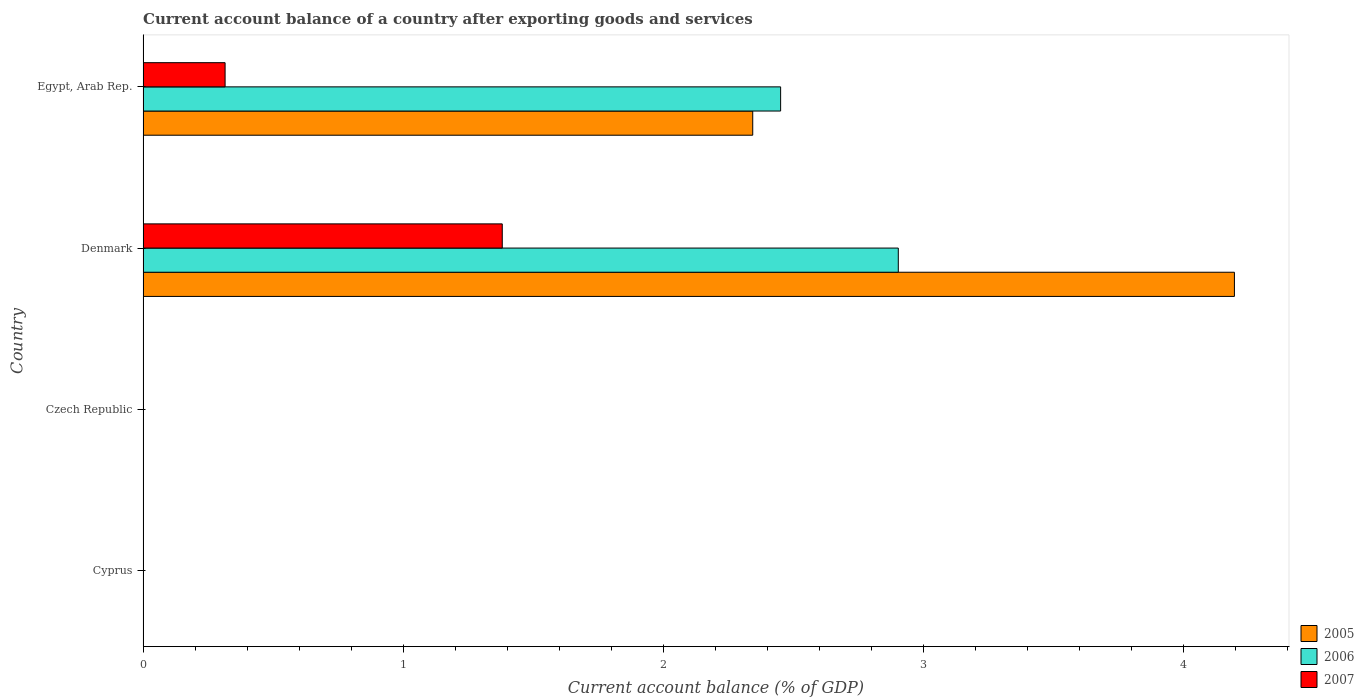How many bars are there on the 1st tick from the bottom?
Make the answer very short. 0. What is the label of the 4th group of bars from the top?
Your response must be concise. Cyprus. What is the account balance in 2007 in Czech Republic?
Provide a succinct answer. 0. Across all countries, what is the maximum account balance in 2007?
Your answer should be compact. 1.38. In which country was the account balance in 2007 maximum?
Provide a succinct answer. Denmark. What is the total account balance in 2005 in the graph?
Make the answer very short. 6.54. What is the difference between the account balance in 2006 in Denmark and that in Egypt, Arab Rep.?
Provide a short and direct response. 0.45. What is the difference between the account balance in 2005 in Denmark and the account balance in 2006 in Egypt, Arab Rep.?
Offer a very short reply. 1.75. What is the average account balance in 2007 per country?
Give a very brief answer. 0.42. What is the difference between the account balance in 2007 and account balance in 2005 in Egypt, Arab Rep.?
Give a very brief answer. -2.03. In how many countries, is the account balance in 2005 greater than 1.2 %?
Your answer should be compact. 2. What is the ratio of the account balance in 2005 in Denmark to that in Egypt, Arab Rep.?
Offer a very short reply. 1.79. Is the account balance in 2007 in Denmark less than that in Egypt, Arab Rep.?
Provide a short and direct response. No. Is the difference between the account balance in 2007 in Denmark and Egypt, Arab Rep. greater than the difference between the account balance in 2005 in Denmark and Egypt, Arab Rep.?
Ensure brevity in your answer.  No. What is the difference between the highest and the lowest account balance in 2006?
Your answer should be very brief. 2.9. In how many countries, is the account balance in 2007 greater than the average account balance in 2007 taken over all countries?
Your answer should be very brief. 1. Is it the case that in every country, the sum of the account balance in 2007 and account balance in 2006 is greater than the account balance in 2005?
Offer a very short reply. No. How many bars are there?
Give a very brief answer. 6. Are all the bars in the graph horizontal?
Provide a short and direct response. Yes. Are the values on the major ticks of X-axis written in scientific E-notation?
Your response must be concise. No. Where does the legend appear in the graph?
Provide a short and direct response. Bottom right. What is the title of the graph?
Your answer should be very brief. Current account balance of a country after exporting goods and services. What is the label or title of the X-axis?
Your answer should be compact. Current account balance (% of GDP). What is the Current account balance (% of GDP) in 2005 in Cyprus?
Make the answer very short. 0. What is the Current account balance (% of GDP) of 2006 in Cyprus?
Provide a succinct answer. 0. What is the Current account balance (% of GDP) of 2006 in Czech Republic?
Your answer should be very brief. 0. What is the Current account balance (% of GDP) of 2005 in Denmark?
Make the answer very short. 4.2. What is the Current account balance (% of GDP) of 2006 in Denmark?
Keep it short and to the point. 2.9. What is the Current account balance (% of GDP) in 2007 in Denmark?
Your answer should be very brief. 1.38. What is the Current account balance (% of GDP) in 2005 in Egypt, Arab Rep.?
Give a very brief answer. 2.34. What is the Current account balance (% of GDP) of 2006 in Egypt, Arab Rep.?
Provide a succinct answer. 2.45. What is the Current account balance (% of GDP) of 2007 in Egypt, Arab Rep.?
Offer a very short reply. 0.32. Across all countries, what is the maximum Current account balance (% of GDP) in 2005?
Give a very brief answer. 4.2. Across all countries, what is the maximum Current account balance (% of GDP) in 2006?
Your answer should be very brief. 2.9. Across all countries, what is the maximum Current account balance (% of GDP) in 2007?
Make the answer very short. 1.38. Across all countries, what is the minimum Current account balance (% of GDP) in 2005?
Your answer should be very brief. 0. Across all countries, what is the minimum Current account balance (% of GDP) in 2006?
Offer a very short reply. 0. Across all countries, what is the minimum Current account balance (% of GDP) in 2007?
Offer a terse response. 0. What is the total Current account balance (% of GDP) in 2005 in the graph?
Ensure brevity in your answer.  6.54. What is the total Current account balance (% of GDP) in 2006 in the graph?
Provide a short and direct response. 5.36. What is the total Current account balance (% of GDP) in 2007 in the graph?
Offer a terse response. 1.7. What is the difference between the Current account balance (% of GDP) in 2005 in Denmark and that in Egypt, Arab Rep.?
Keep it short and to the point. 1.85. What is the difference between the Current account balance (% of GDP) in 2006 in Denmark and that in Egypt, Arab Rep.?
Keep it short and to the point. 0.45. What is the difference between the Current account balance (% of GDP) of 2007 in Denmark and that in Egypt, Arab Rep.?
Provide a short and direct response. 1.07. What is the difference between the Current account balance (% of GDP) in 2005 in Denmark and the Current account balance (% of GDP) in 2006 in Egypt, Arab Rep.?
Ensure brevity in your answer.  1.75. What is the difference between the Current account balance (% of GDP) of 2005 in Denmark and the Current account balance (% of GDP) of 2007 in Egypt, Arab Rep.?
Provide a succinct answer. 3.88. What is the difference between the Current account balance (% of GDP) of 2006 in Denmark and the Current account balance (% of GDP) of 2007 in Egypt, Arab Rep.?
Offer a terse response. 2.59. What is the average Current account balance (% of GDP) in 2005 per country?
Ensure brevity in your answer.  1.64. What is the average Current account balance (% of GDP) of 2006 per country?
Your answer should be compact. 1.34. What is the average Current account balance (% of GDP) in 2007 per country?
Keep it short and to the point. 0.42. What is the difference between the Current account balance (% of GDP) in 2005 and Current account balance (% of GDP) in 2006 in Denmark?
Make the answer very short. 1.29. What is the difference between the Current account balance (% of GDP) of 2005 and Current account balance (% of GDP) of 2007 in Denmark?
Offer a very short reply. 2.82. What is the difference between the Current account balance (% of GDP) of 2006 and Current account balance (% of GDP) of 2007 in Denmark?
Provide a short and direct response. 1.52. What is the difference between the Current account balance (% of GDP) in 2005 and Current account balance (% of GDP) in 2006 in Egypt, Arab Rep.?
Offer a very short reply. -0.11. What is the difference between the Current account balance (% of GDP) of 2005 and Current account balance (% of GDP) of 2007 in Egypt, Arab Rep.?
Give a very brief answer. 2.03. What is the difference between the Current account balance (% of GDP) of 2006 and Current account balance (% of GDP) of 2007 in Egypt, Arab Rep.?
Keep it short and to the point. 2.14. What is the ratio of the Current account balance (% of GDP) in 2005 in Denmark to that in Egypt, Arab Rep.?
Provide a succinct answer. 1.79. What is the ratio of the Current account balance (% of GDP) in 2006 in Denmark to that in Egypt, Arab Rep.?
Provide a short and direct response. 1.18. What is the ratio of the Current account balance (% of GDP) in 2007 in Denmark to that in Egypt, Arab Rep.?
Offer a terse response. 4.38. What is the difference between the highest and the lowest Current account balance (% of GDP) in 2005?
Your response must be concise. 4.2. What is the difference between the highest and the lowest Current account balance (% of GDP) in 2006?
Your answer should be compact. 2.9. What is the difference between the highest and the lowest Current account balance (% of GDP) of 2007?
Your answer should be very brief. 1.38. 